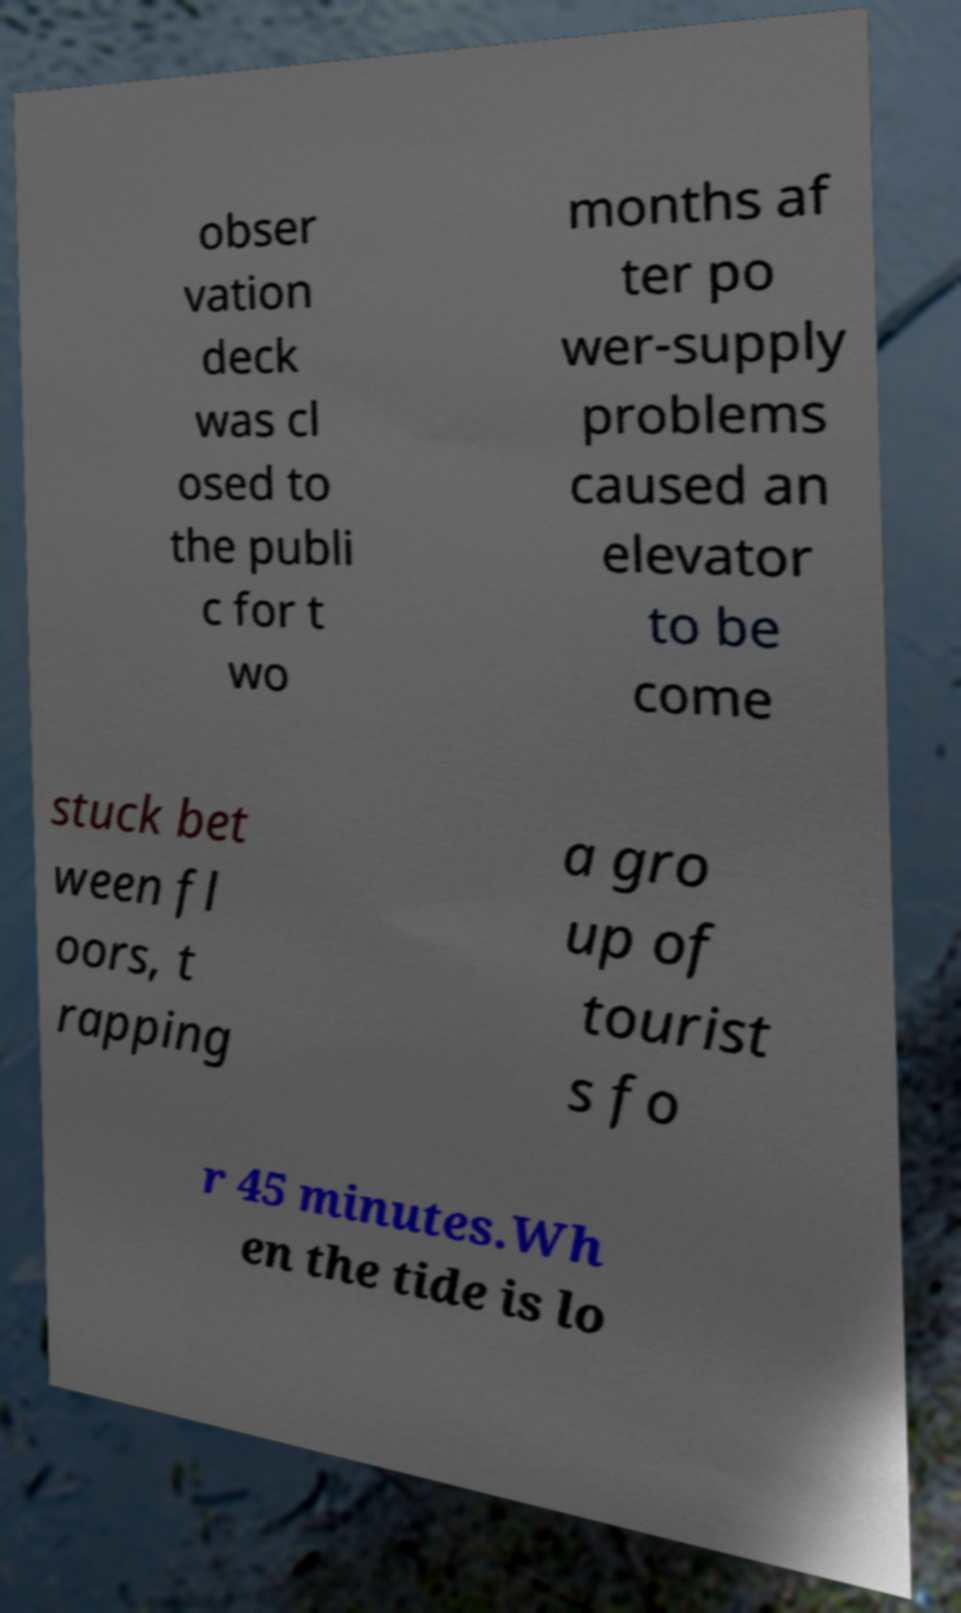For documentation purposes, I need the text within this image transcribed. Could you provide that? obser vation deck was cl osed to the publi c for t wo months af ter po wer-supply problems caused an elevator to be come stuck bet ween fl oors, t rapping a gro up of tourist s fo r 45 minutes.Wh en the tide is lo 